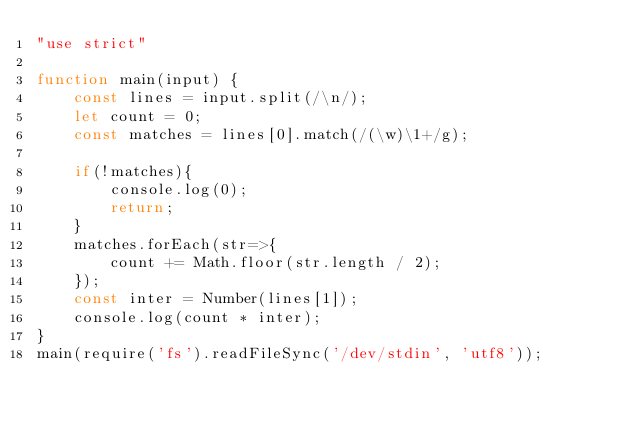Convert code to text. <code><loc_0><loc_0><loc_500><loc_500><_JavaScript_>"use strict"

function main(input) {
    const lines = input.split(/\n/);
    let count = 0;
    const matches = lines[0].match(/(\w)\1+/g);
    
    if(!matches){
        console.log(0);
        return;
    }
    matches.forEach(str=>{
        count += Math.floor(str.length / 2);
    });
    const inter = Number(lines[1]);
    console.log(count * inter);
}
main(require('fs').readFileSync('/dev/stdin', 'utf8'));</code> 